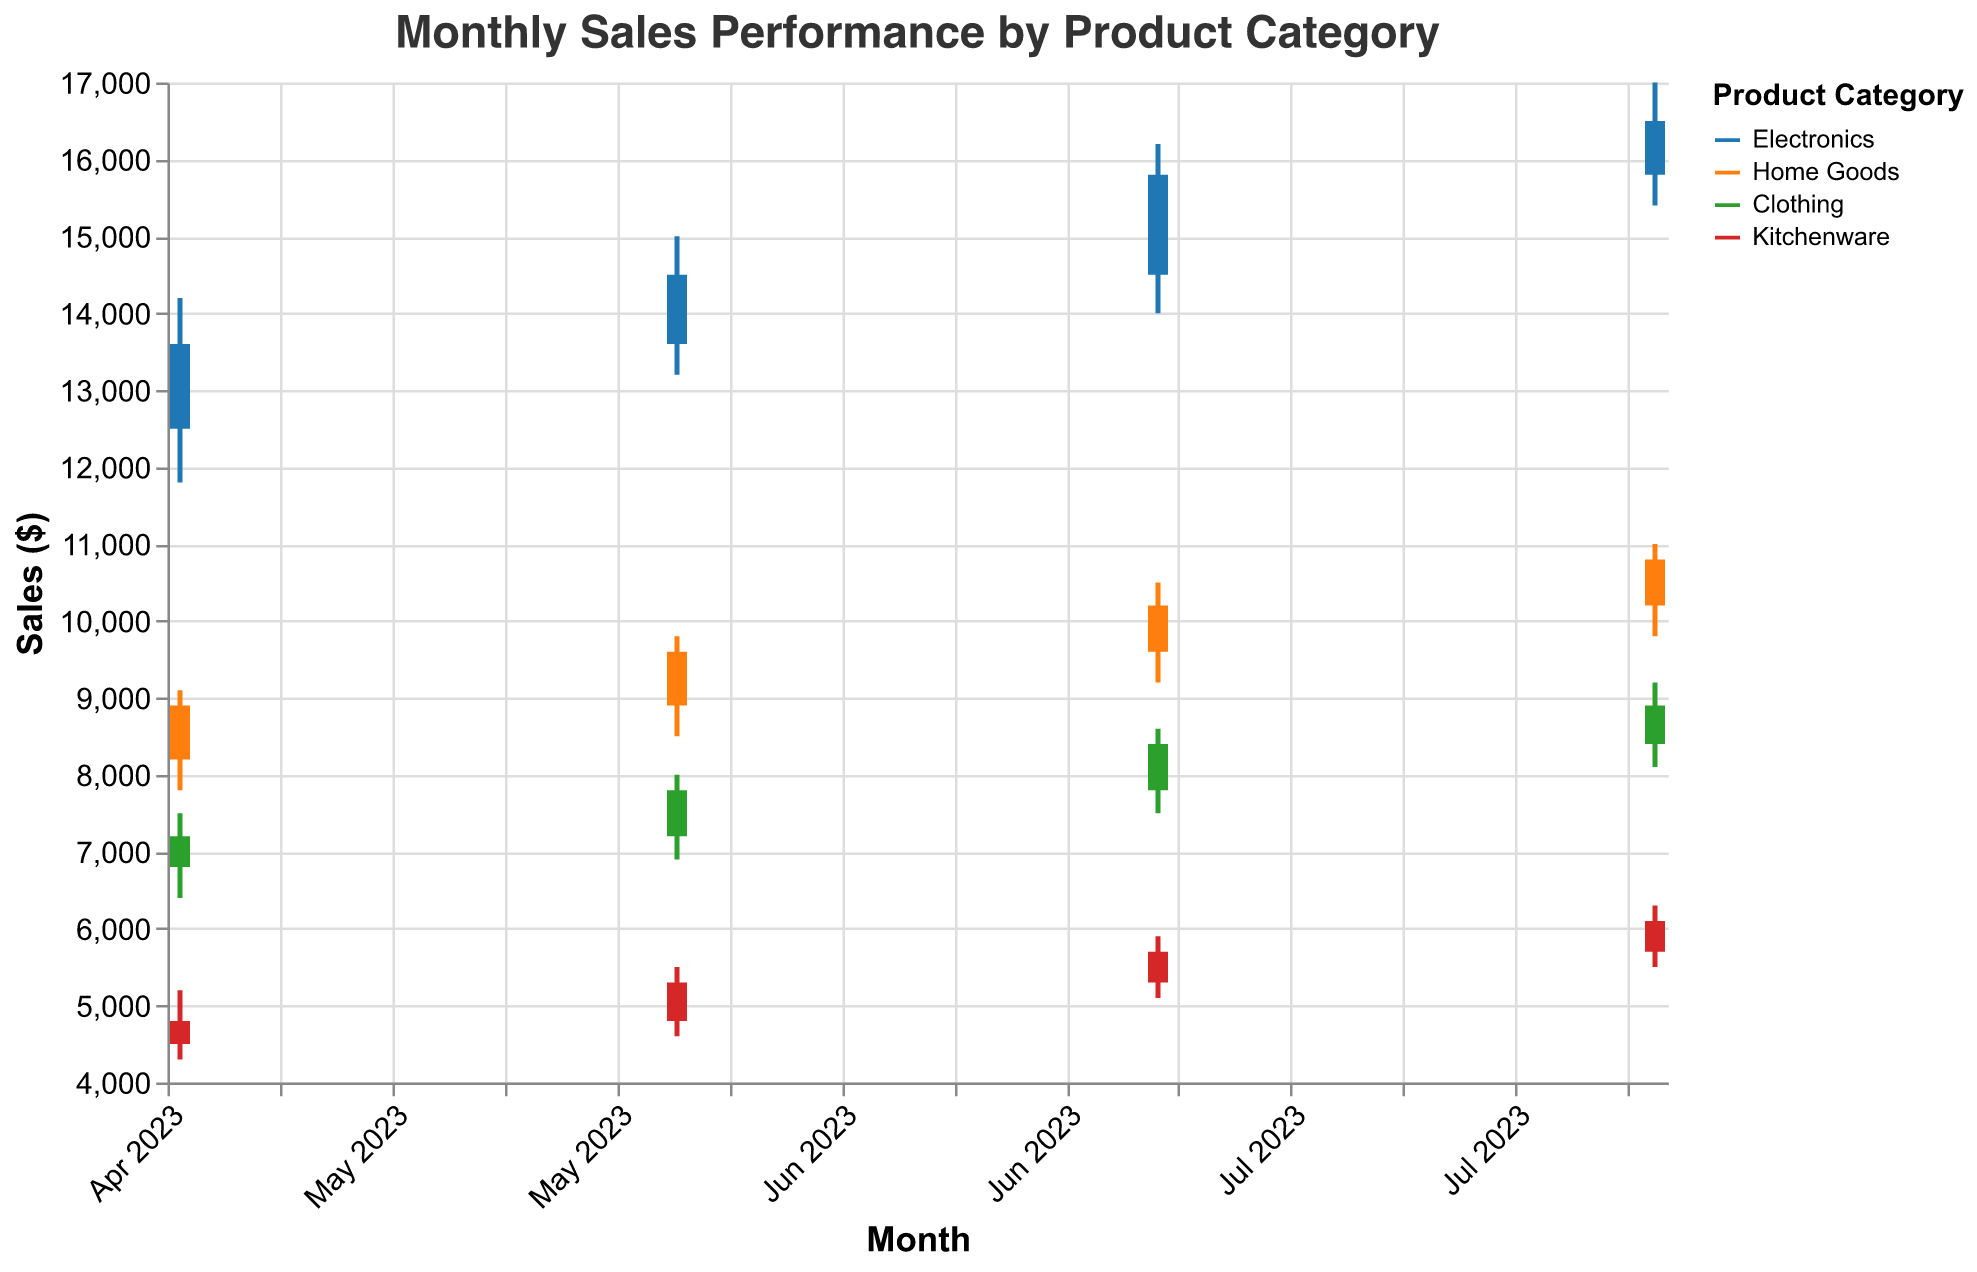what is the title of the plot? The title of the plot is usually found at the top of the figure. It gives a summary of what the figure represents. In this case, the title is "Monthly Sales Performance by Product Category"
Answer: Monthly Sales Performance by Product Category Which category had the highest close value in August 2023? Look for the highest close value in August 2023 across all categories. In this case, Electronics had a close value of 16500, which is the highest.
Answer: Electronics How did the sales performance of Home Goods change between June and July 2023? To determine the change in sales performance, look at the close values for Home Goods in June and July. The close value for Home Goods in June is 9600 and in July is 10200, indicating an increase.
Answer: Increased Which product category shows the least volatility in May 2023? Volatility can be assessed by the range (difference between the high and low values). In May 2023, Kitchenware has the least volatility (High: 5200, Low: 4300, difference: 900) compared to other categories.
Answer: Kitchenware Did any category have a closing value lower than its opening value in July 2023? Compare the open and close values for each category in July 2023. All categories (Electronics, Home Goods, Clothing, Kitchenware) have closing values higher than their opening values, so none had a lower closing value.
Answer: No Which month shows the highest increase in sales for Clothing? Examine the difference between close and open values for Clothing across all months. The highest increase is in July 2023 where the close value (8400) minus the open value (7800) gives the highest positive change of 600.
Answer: July 2023 How did Kitchenware sales perform from June to August 2023? Look at the closing values for Kitchenware from June to August. The values are: June - 5300, July - 5700, August - 6100, indicating a consistent increase over these months.
Answer: Increased consistently What is the color representation for Electronics and Home Goods? Colors representing each category are shown in the legend. The color for Electronics is blue, and for Home Goods, it is orange.
Answer: blue for Electronics, orange for Home Goods Which category had the highest peak (high value) in the observed period? Compare the high values for all categories over the given months. Electronics had the highest peak value of 17000 in August 2023.
Answer: Electronics Was there any category that had a consistent increase in closing values each month? Evaluate the closing values for each category month by month. Electronics shows consistent increases in closing values: May - 13600, June - 14500, July - 15800, August - 16500.
Answer: Electronics 